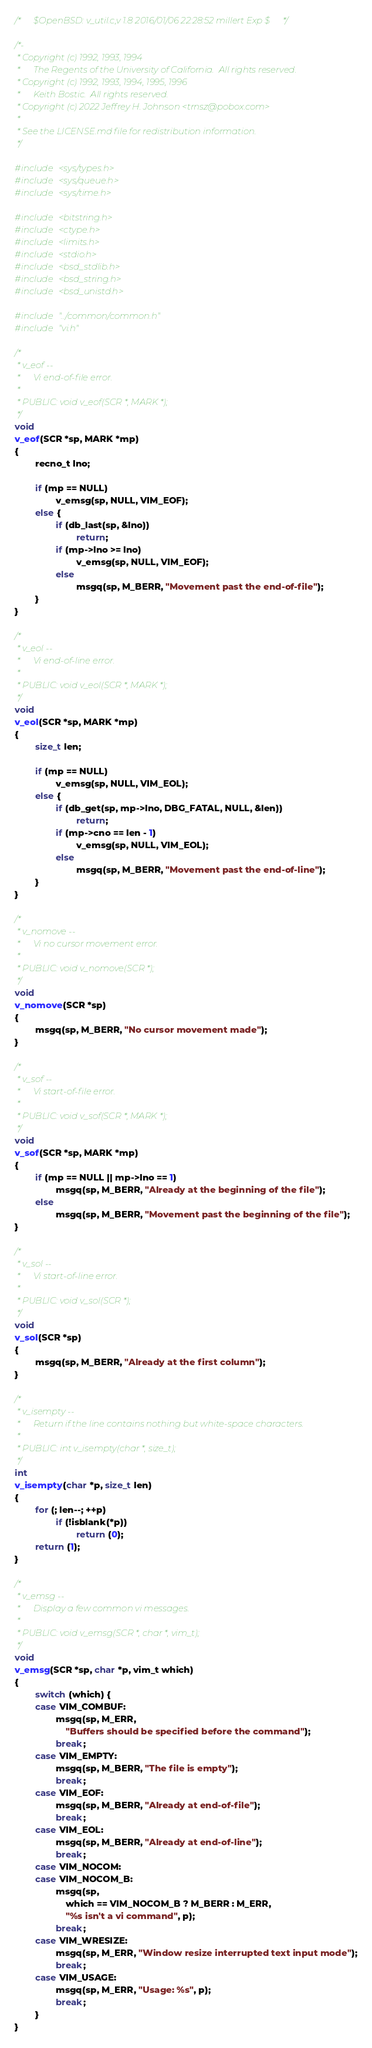Convert code to text. <code><loc_0><loc_0><loc_500><loc_500><_C_>/*      $OpenBSD: v_util.c,v 1.8 2016/01/06 22:28:52 millert Exp $      */

/*-
 * Copyright (c) 1992, 1993, 1994
 *      The Regents of the University of California.  All rights reserved.
 * Copyright (c) 1992, 1993, 1994, 1995, 1996
 *      Keith Bostic.  All rights reserved.
 * Copyright (c) 2022 Jeffrey H. Johnson <trnsz@pobox.com>
 *
 * See the LICENSE.md file for redistribution information.
 */

#include <sys/types.h>
#include <sys/queue.h>
#include <sys/time.h>

#include <bitstring.h>
#include <ctype.h>
#include <limits.h>
#include <stdio.h>
#include <bsd_stdlib.h>
#include <bsd_string.h>
#include <bsd_unistd.h>

#include "../common/common.h"
#include "vi.h"

/*
 * v_eof --
 *      Vi end-of-file error.
 *
 * PUBLIC: void v_eof(SCR *, MARK *);
 */
void
v_eof(SCR *sp, MARK *mp)
{
        recno_t lno;

        if (mp == NULL)
                v_emsg(sp, NULL, VIM_EOF);
        else {
                if (db_last(sp, &lno))
                        return;
                if (mp->lno >= lno)
                        v_emsg(sp, NULL, VIM_EOF);
                else
                        msgq(sp, M_BERR, "Movement past the end-of-file");
        }
}

/*
 * v_eol --
 *      Vi end-of-line error.
 *
 * PUBLIC: void v_eol(SCR *, MARK *);
 */
void
v_eol(SCR *sp, MARK *mp)
{
        size_t len;

        if (mp == NULL)
                v_emsg(sp, NULL, VIM_EOL);
        else {
                if (db_get(sp, mp->lno, DBG_FATAL, NULL, &len))
                        return;
                if (mp->cno == len - 1)
                        v_emsg(sp, NULL, VIM_EOL);
                else
                        msgq(sp, M_BERR, "Movement past the end-of-line");
        }
}

/*
 * v_nomove --
 *      Vi no cursor movement error.
 *
 * PUBLIC: void v_nomove(SCR *);
 */
void
v_nomove(SCR *sp)
{
        msgq(sp, M_BERR, "No cursor movement made");
}

/*
 * v_sof --
 *      Vi start-of-file error.
 *
 * PUBLIC: void v_sof(SCR *, MARK *);
 */
void
v_sof(SCR *sp, MARK *mp)
{
        if (mp == NULL || mp->lno == 1)
                msgq(sp, M_BERR, "Already at the beginning of the file");
        else
                msgq(sp, M_BERR, "Movement past the beginning of the file");
}

/*
 * v_sol --
 *      Vi start-of-line error.
 *
 * PUBLIC: void v_sol(SCR *);
 */
void
v_sol(SCR *sp)
{
        msgq(sp, M_BERR, "Already at the first column");
}

/*
 * v_isempty --
 *      Return if the line contains nothing but white-space characters.
 *
 * PUBLIC: int v_isempty(char *, size_t);
 */
int
v_isempty(char *p, size_t len)
{
        for (; len--; ++p)
                if (!isblank(*p))
                        return (0);
        return (1);
}

/*
 * v_emsg --
 *      Display a few common vi messages.
 *
 * PUBLIC: void v_emsg(SCR *, char *, vim_t);
 */
void
v_emsg(SCR *sp, char *p, vim_t which)
{
        switch (which) {
        case VIM_COMBUF:
                msgq(sp, M_ERR,
                    "Buffers should be specified before the command");
                break;
        case VIM_EMPTY:
                msgq(sp, M_BERR, "The file is empty");
                break;
        case VIM_EOF:
                msgq(sp, M_BERR, "Already at end-of-file");
                break;
        case VIM_EOL:
                msgq(sp, M_BERR, "Already at end-of-line");
                break;
        case VIM_NOCOM:
        case VIM_NOCOM_B:
                msgq(sp,
                    which == VIM_NOCOM_B ? M_BERR : M_ERR,
                    "%s isn't a vi command", p);
                break;
        case VIM_WRESIZE:
                msgq(sp, M_ERR, "Window resize interrupted text input mode");
                break;
        case VIM_USAGE:
                msgq(sp, M_ERR, "Usage: %s", p);
                break;
        }
}
</code> 